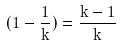<formula> <loc_0><loc_0><loc_500><loc_500>( 1 - \frac { 1 } { k } ) = \frac { k - 1 } { k }</formula> 